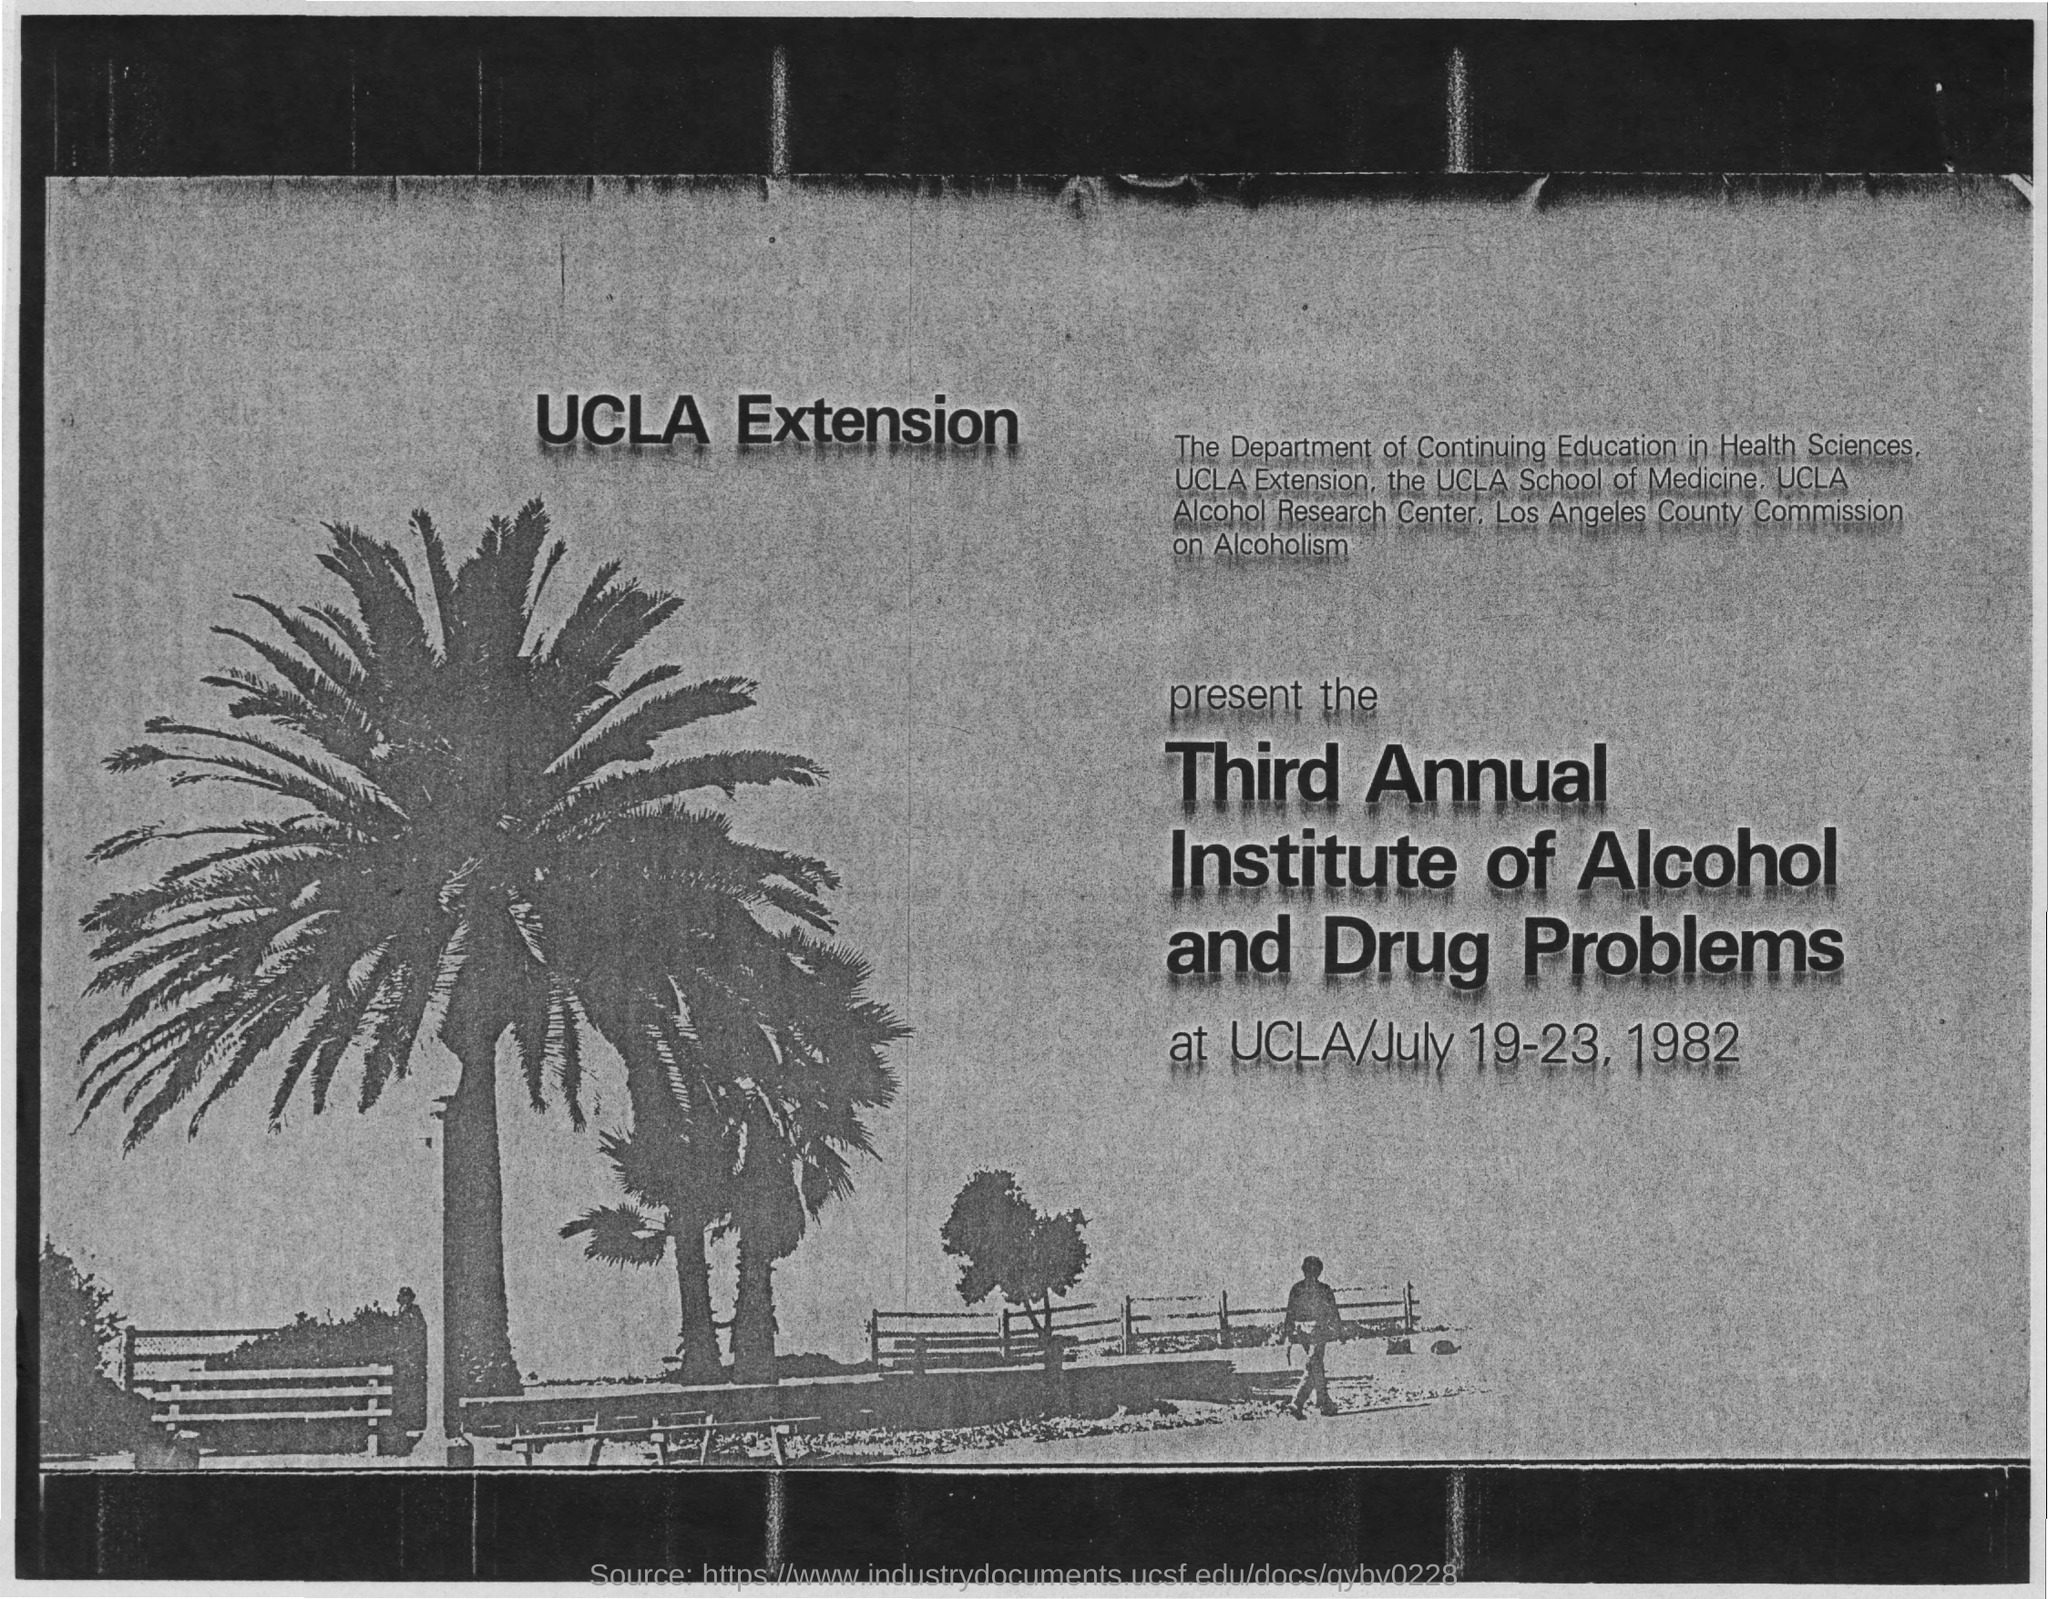Where is the program?
Ensure brevity in your answer.  Ucla. When is the program going to be held?
Keep it short and to the point. July 19-23, 1982. 